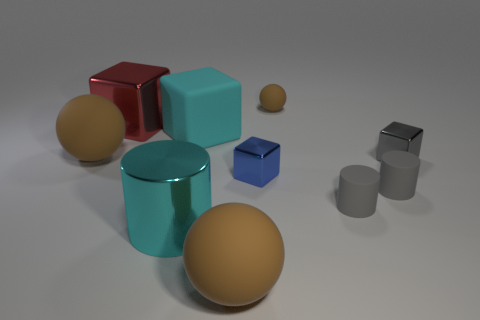Subtract all blocks. How many objects are left? 6 Add 4 small brown rubber balls. How many small brown rubber balls are left? 5 Add 2 large cyan objects. How many large cyan objects exist? 4 Subtract 1 gray blocks. How many objects are left? 9 Subtract all cyan metal balls. Subtract all metallic cubes. How many objects are left? 7 